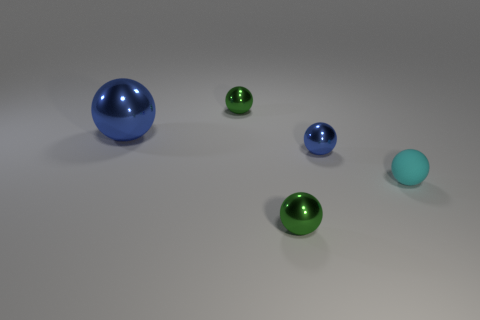Subtract all tiny cyan balls. How many balls are left? 4 Subtract all cyan spheres. How many spheres are left? 4 Subtract all gray balls. Subtract all green blocks. How many balls are left? 5 Add 2 metal spheres. How many objects exist? 7 Subtract all red metallic cylinders. Subtract all large shiny things. How many objects are left? 4 Add 3 blue metal balls. How many blue metal balls are left? 5 Add 2 small cyan matte balls. How many small cyan matte balls exist? 3 Subtract 0 brown cubes. How many objects are left? 5 